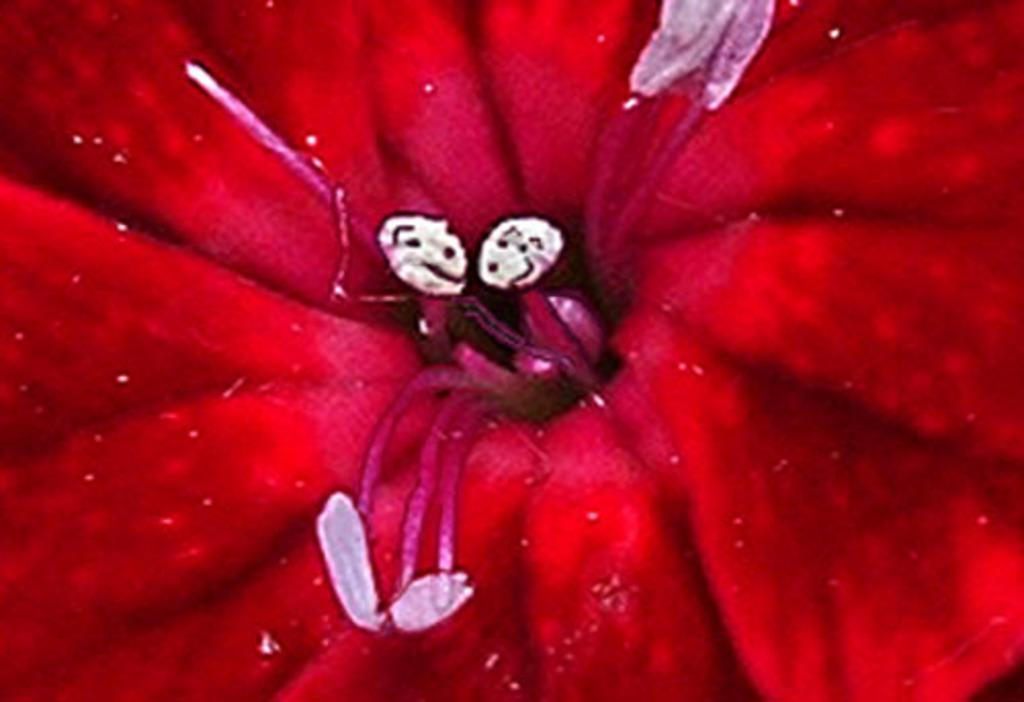What type of flower is present in the image? There is a red color flower in the image. What type of pickle is placed near the flower in the image? There is no pickle present in the image; it only features a red color flower. What is the interest rate for the loan mentioned in the image? There is no mention of a loan or interest rate in the image; it only features a red color flower. 